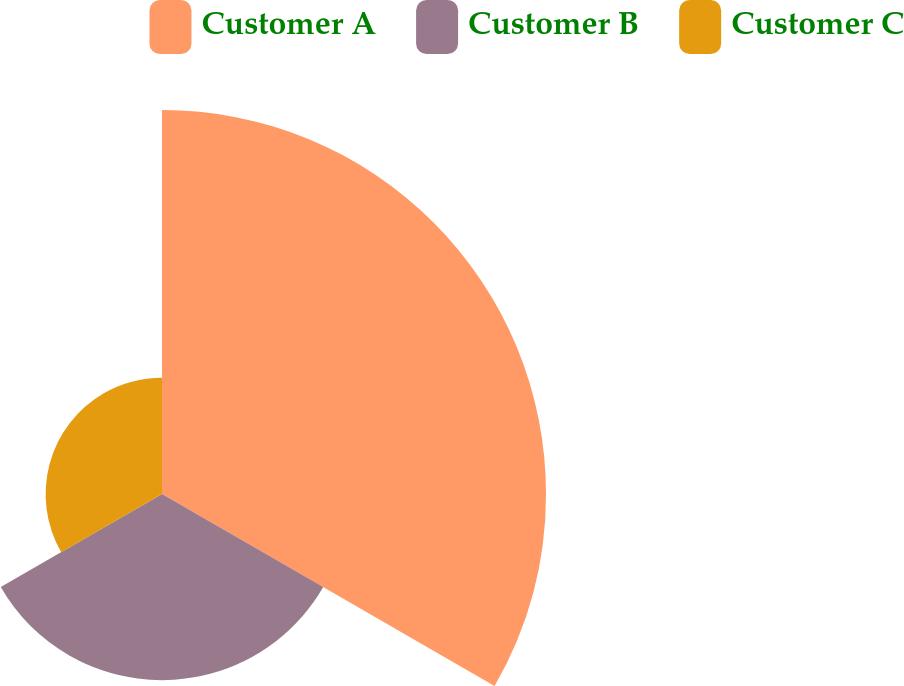<chart> <loc_0><loc_0><loc_500><loc_500><pie_chart><fcel>Customer A<fcel>Customer B<fcel>Customer C<nl><fcel>55.93%<fcel>27.12%<fcel>16.95%<nl></chart> 